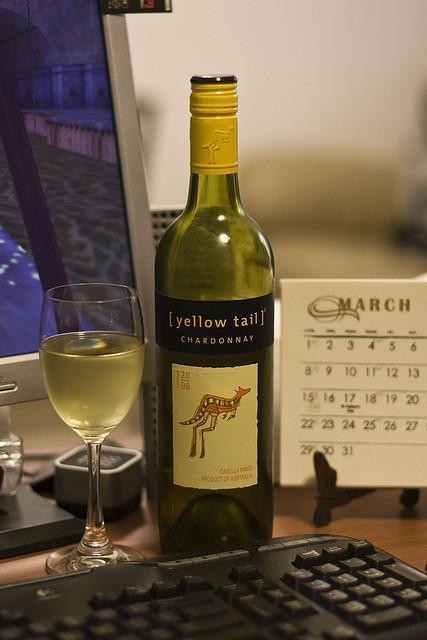How many bottles are there?
Give a very brief answer. 1. How many bottles are on the table?
Give a very brief answer. 1. 